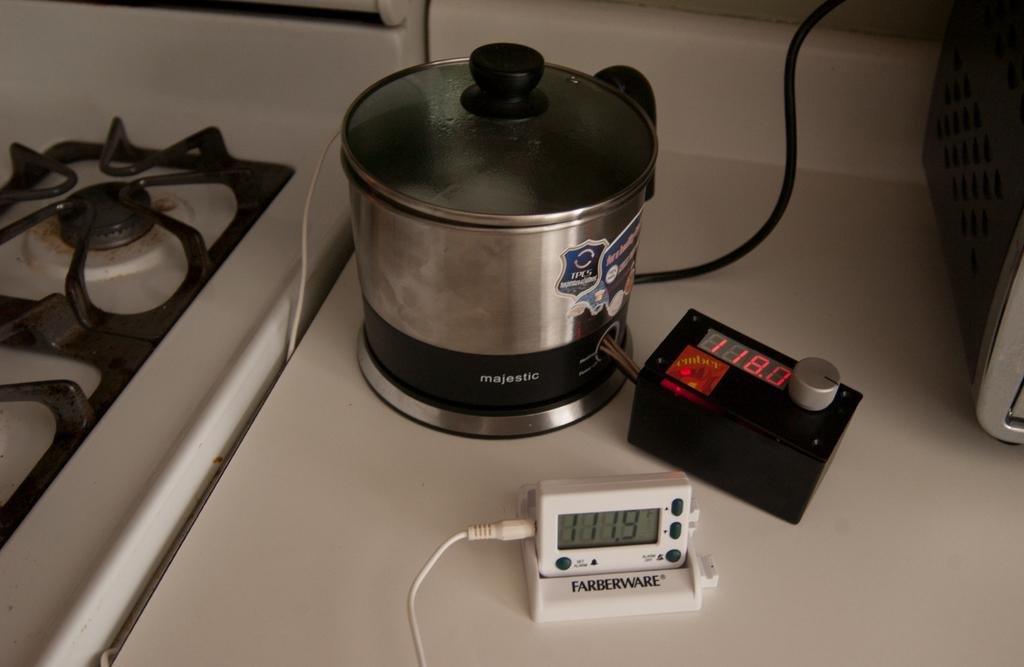<image>
Relay a brief, clear account of the picture shown. A Majestic brand appliance sits next to a Farberware timer. 